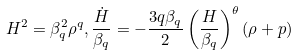<formula> <loc_0><loc_0><loc_500><loc_500>H ^ { 2 } = \beta ^ { 2 } _ { q } \rho ^ { q } , \frac { \dot { H } } { \beta _ { q } } = - \frac { 3 q \beta _ { q } } { 2 } \left ( \frac { H } { \beta _ { q } } \right ) ^ { \theta } ( \rho + p )</formula> 